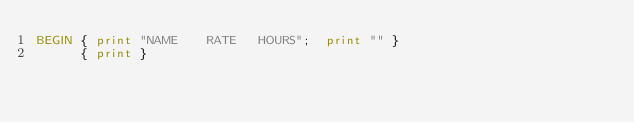Convert code to text. <code><loc_0><loc_0><loc_500><loc_500><_Awk_>BEGIN { print "NAME    RATE   HOURS";  print "" }
      { print }
</code> 